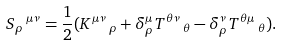<formula> <loc_0><loc_0><loc_500><loc_500>S _ { \rho } \, ^ { \mu \nu } = \frac { 1 } { 2 } ( K ^ { \mu \nu } \, _ { \rho } + \delta ^ { \mu } _ { \rho } T ^ { \theta \nu } \, _ { \theta } - \delta ^ { \nu } _ { \rho } T ^ { \theta \mu } \, _ { \theta } ) .</formula> 